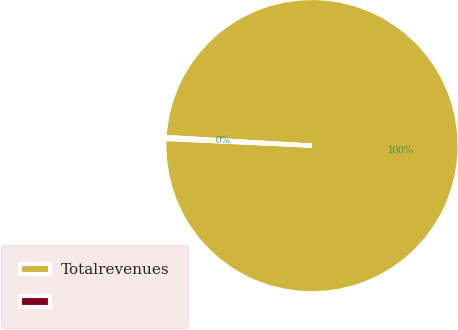<chart> <loc_0><loc_0><loc_500><loc_500><pie_chart><fcel>Totalrevenues<fcel>Unnamed: 1<nl><fcel>99.79%<fcel>0.21%<nl></chart> 